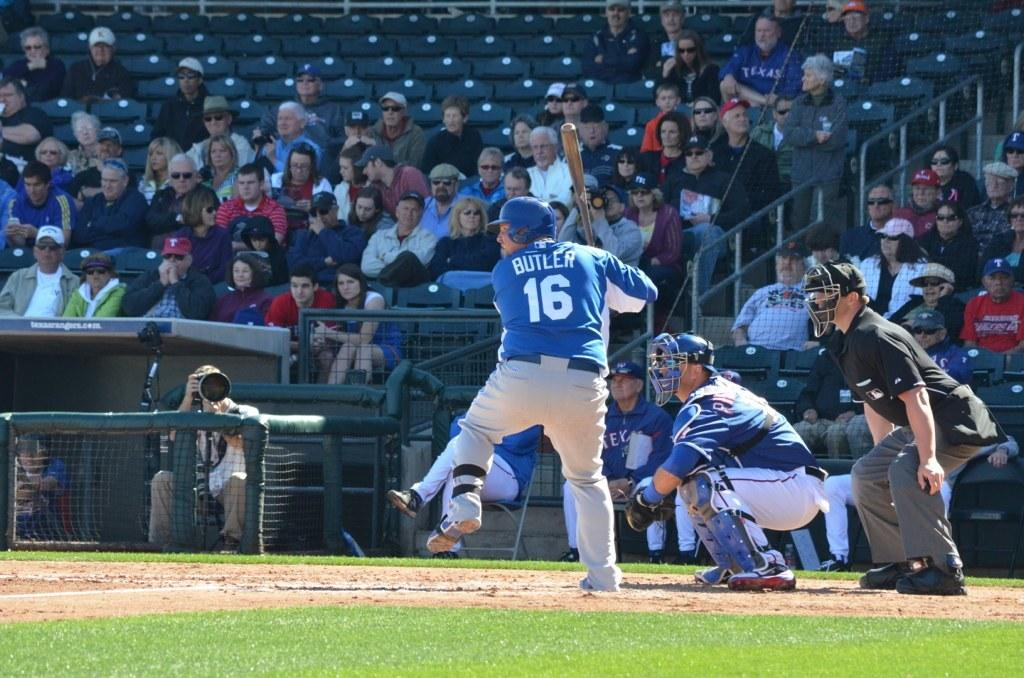<image>
Relay a brief, clear account of the picture shown. A baseball player named Butler has the number 16 on his blue shirt. 